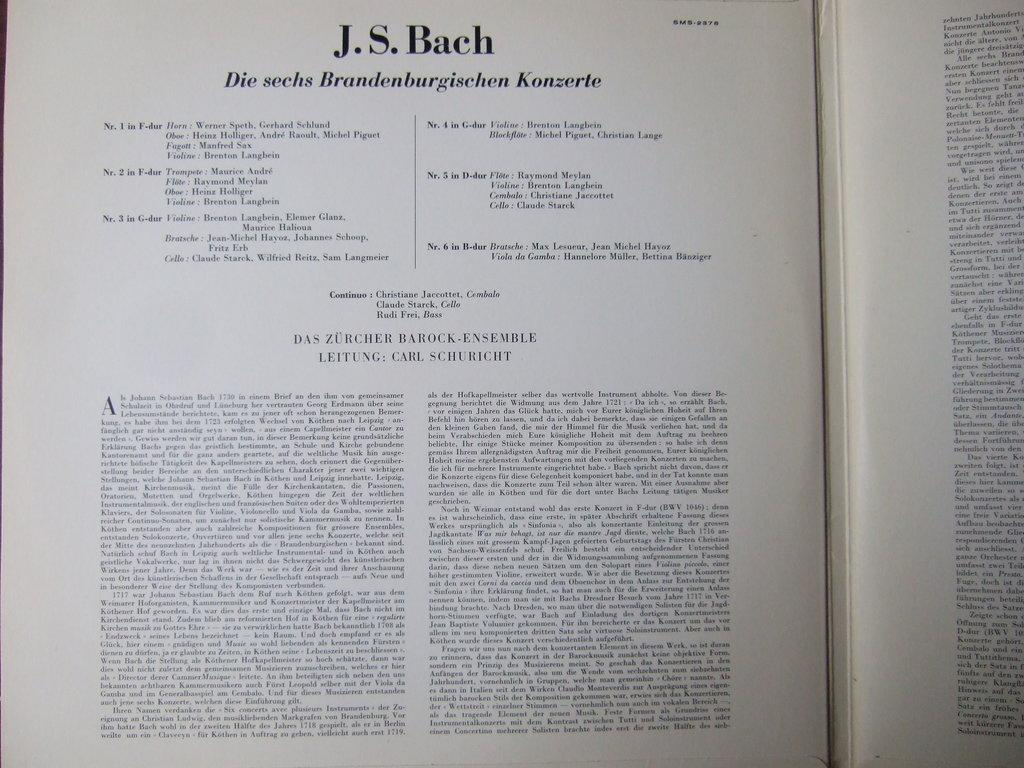<image>
Write a terse but informative summary of the picture. A book that talks about musician J.S. Bach is open. 